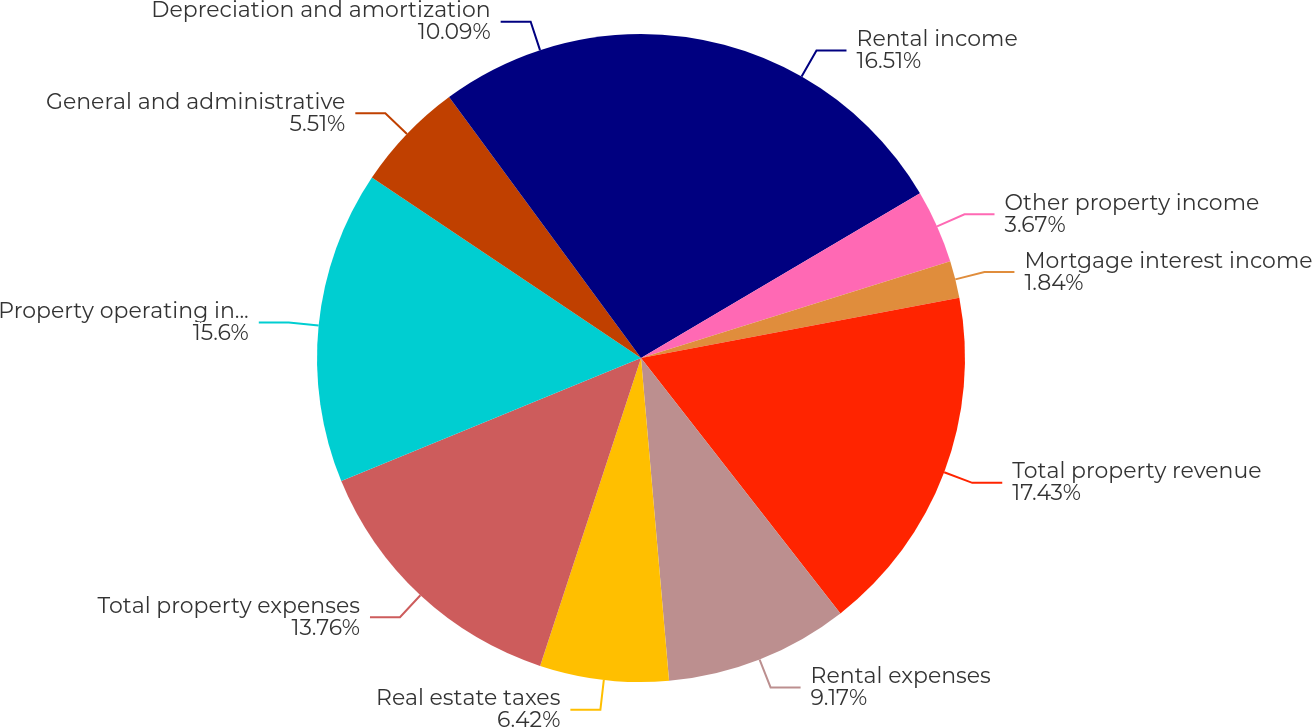Convert chart to OTSL. <chart><loc_0><loc_0><loc_500><loc_500><pie_chart><fcel>Rental income<fcel>Other property income<fcel>Mortgage interest income<fcel>Total property revenue<fcel>Rental expenses<fcel>Real estate taxes<fcel>Total property expenses<fcel>Property operating income (1)<fcel>General and administrative<fcel>Depreciation and amortization<nl><fcel>16.51%<fcel>3.67%<fcel>1.84%<fcel>17.43%<fcel>9.17%<fcel>6.42%<fcel>13.76%<fcel>15.6%<fcel>5.51%<fcel>10.09%<nl></chart> 